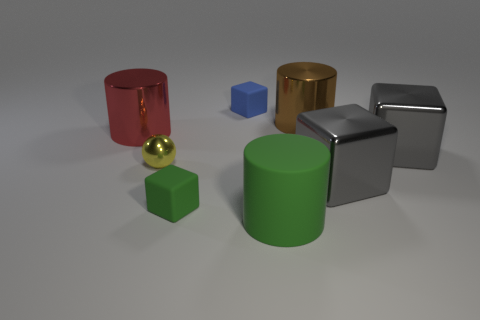What material is the ball?
Provide a short and direct response. Metal. There is a cube that is the same color as the large matte cylinder; what size is it?
Make the answer very short. Small. Do the big red metal object and the green rubber thing that is behind the big green matte cylinder have the same shape?
Give a very brief answer. No. What is the thing in front of the green matte object that is on the left side of the cube behind the brown thing made of?
Your response must be concise. Rubber. What number of yellow shiny things are there?
Offer a very short reply. 1. How many purple objects are either metallic things or small balls?
Make the answer very short. 0. What number of other things are the same shape as the tiny yellow metallic object?
Your response must be concise. 0. Does the small rubber object in front of the big brown cylinder have the same color as the big block behind the yellow shiny ball?
Your answer should be very brief. No. What number of small things are blue metal spheres or red shiny cylinders?
Offer a very short reply. 0. The red thing that is the same shape as the big green matte object is what size?
Give a very brief answer. Large. 